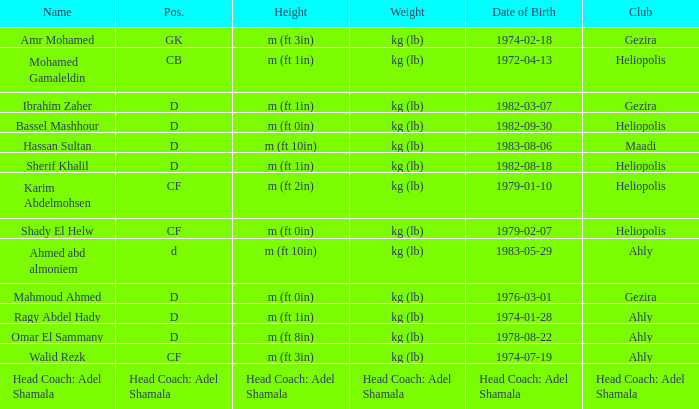What is Weight, when Club is "Ahly", and when Name is "Ragy Abdel Hady"? Kg (lb). 